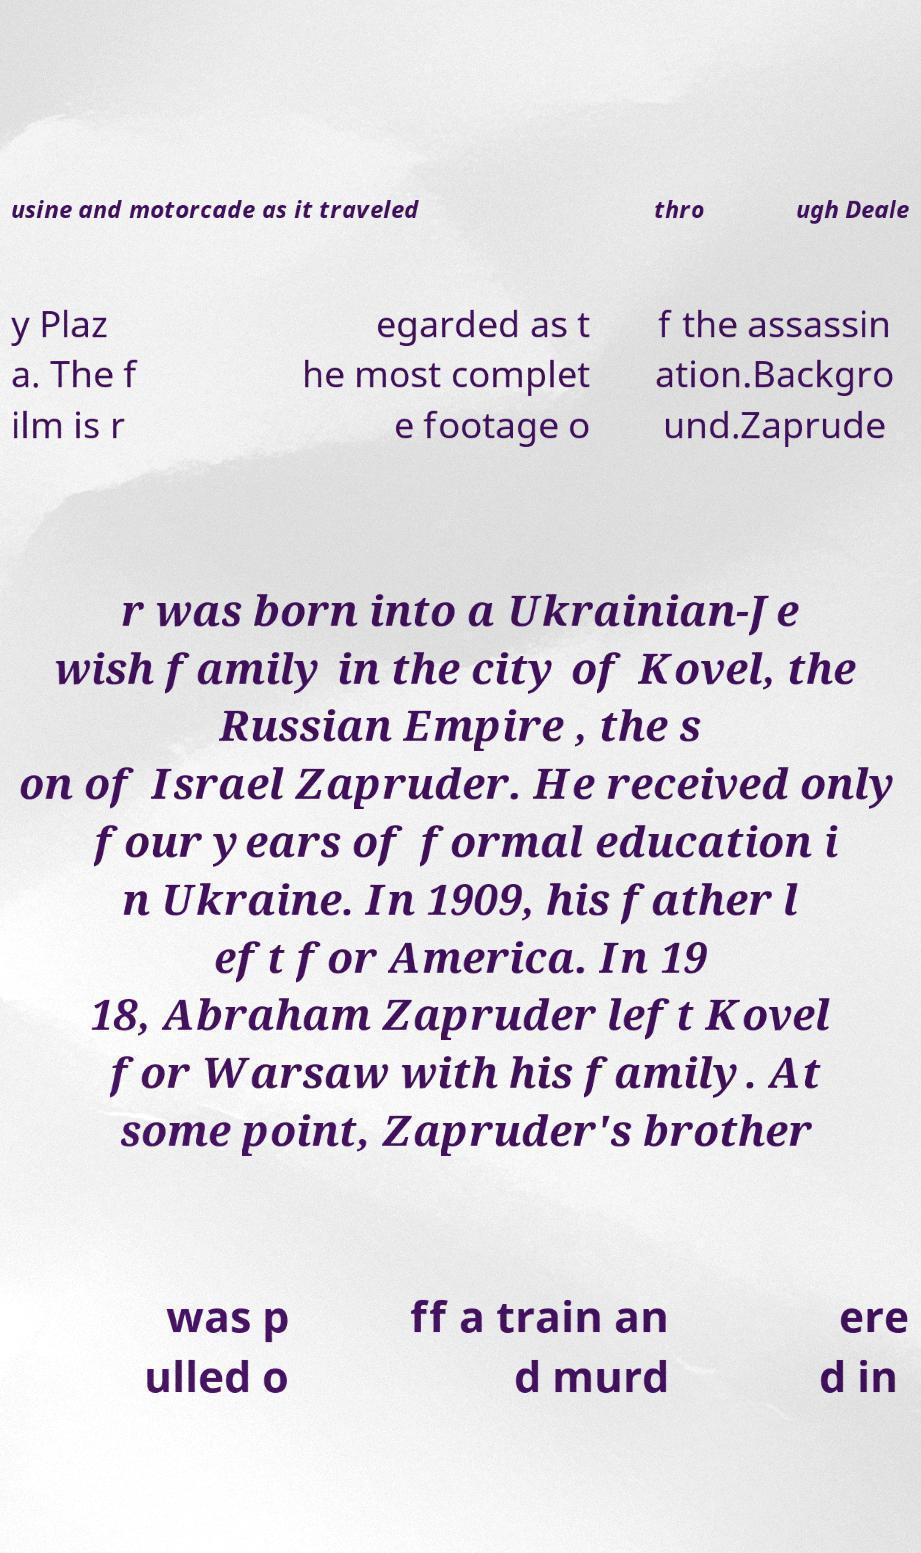Can you accurately transcribe the text from the provided image for me? usine and motorcade as it traveled thro ugh Deale y Plaz a. The f ilm is r egarded as t he most complet e footage o f the assassin ation.Backgro und.Zaprude r was born into a Ukrainian-Je wish family in the city of Kovel, the Russian Empire , the s on of Israel Zapruder. He received only four years of formal education i n Ukraine. In 1909, his father l eft for America. In 19 18, Abraham Zapruder left Kovel for Warsaw with his family. At some point, Zapruder's brother was p ulled o ff a train an d murd ere d in 